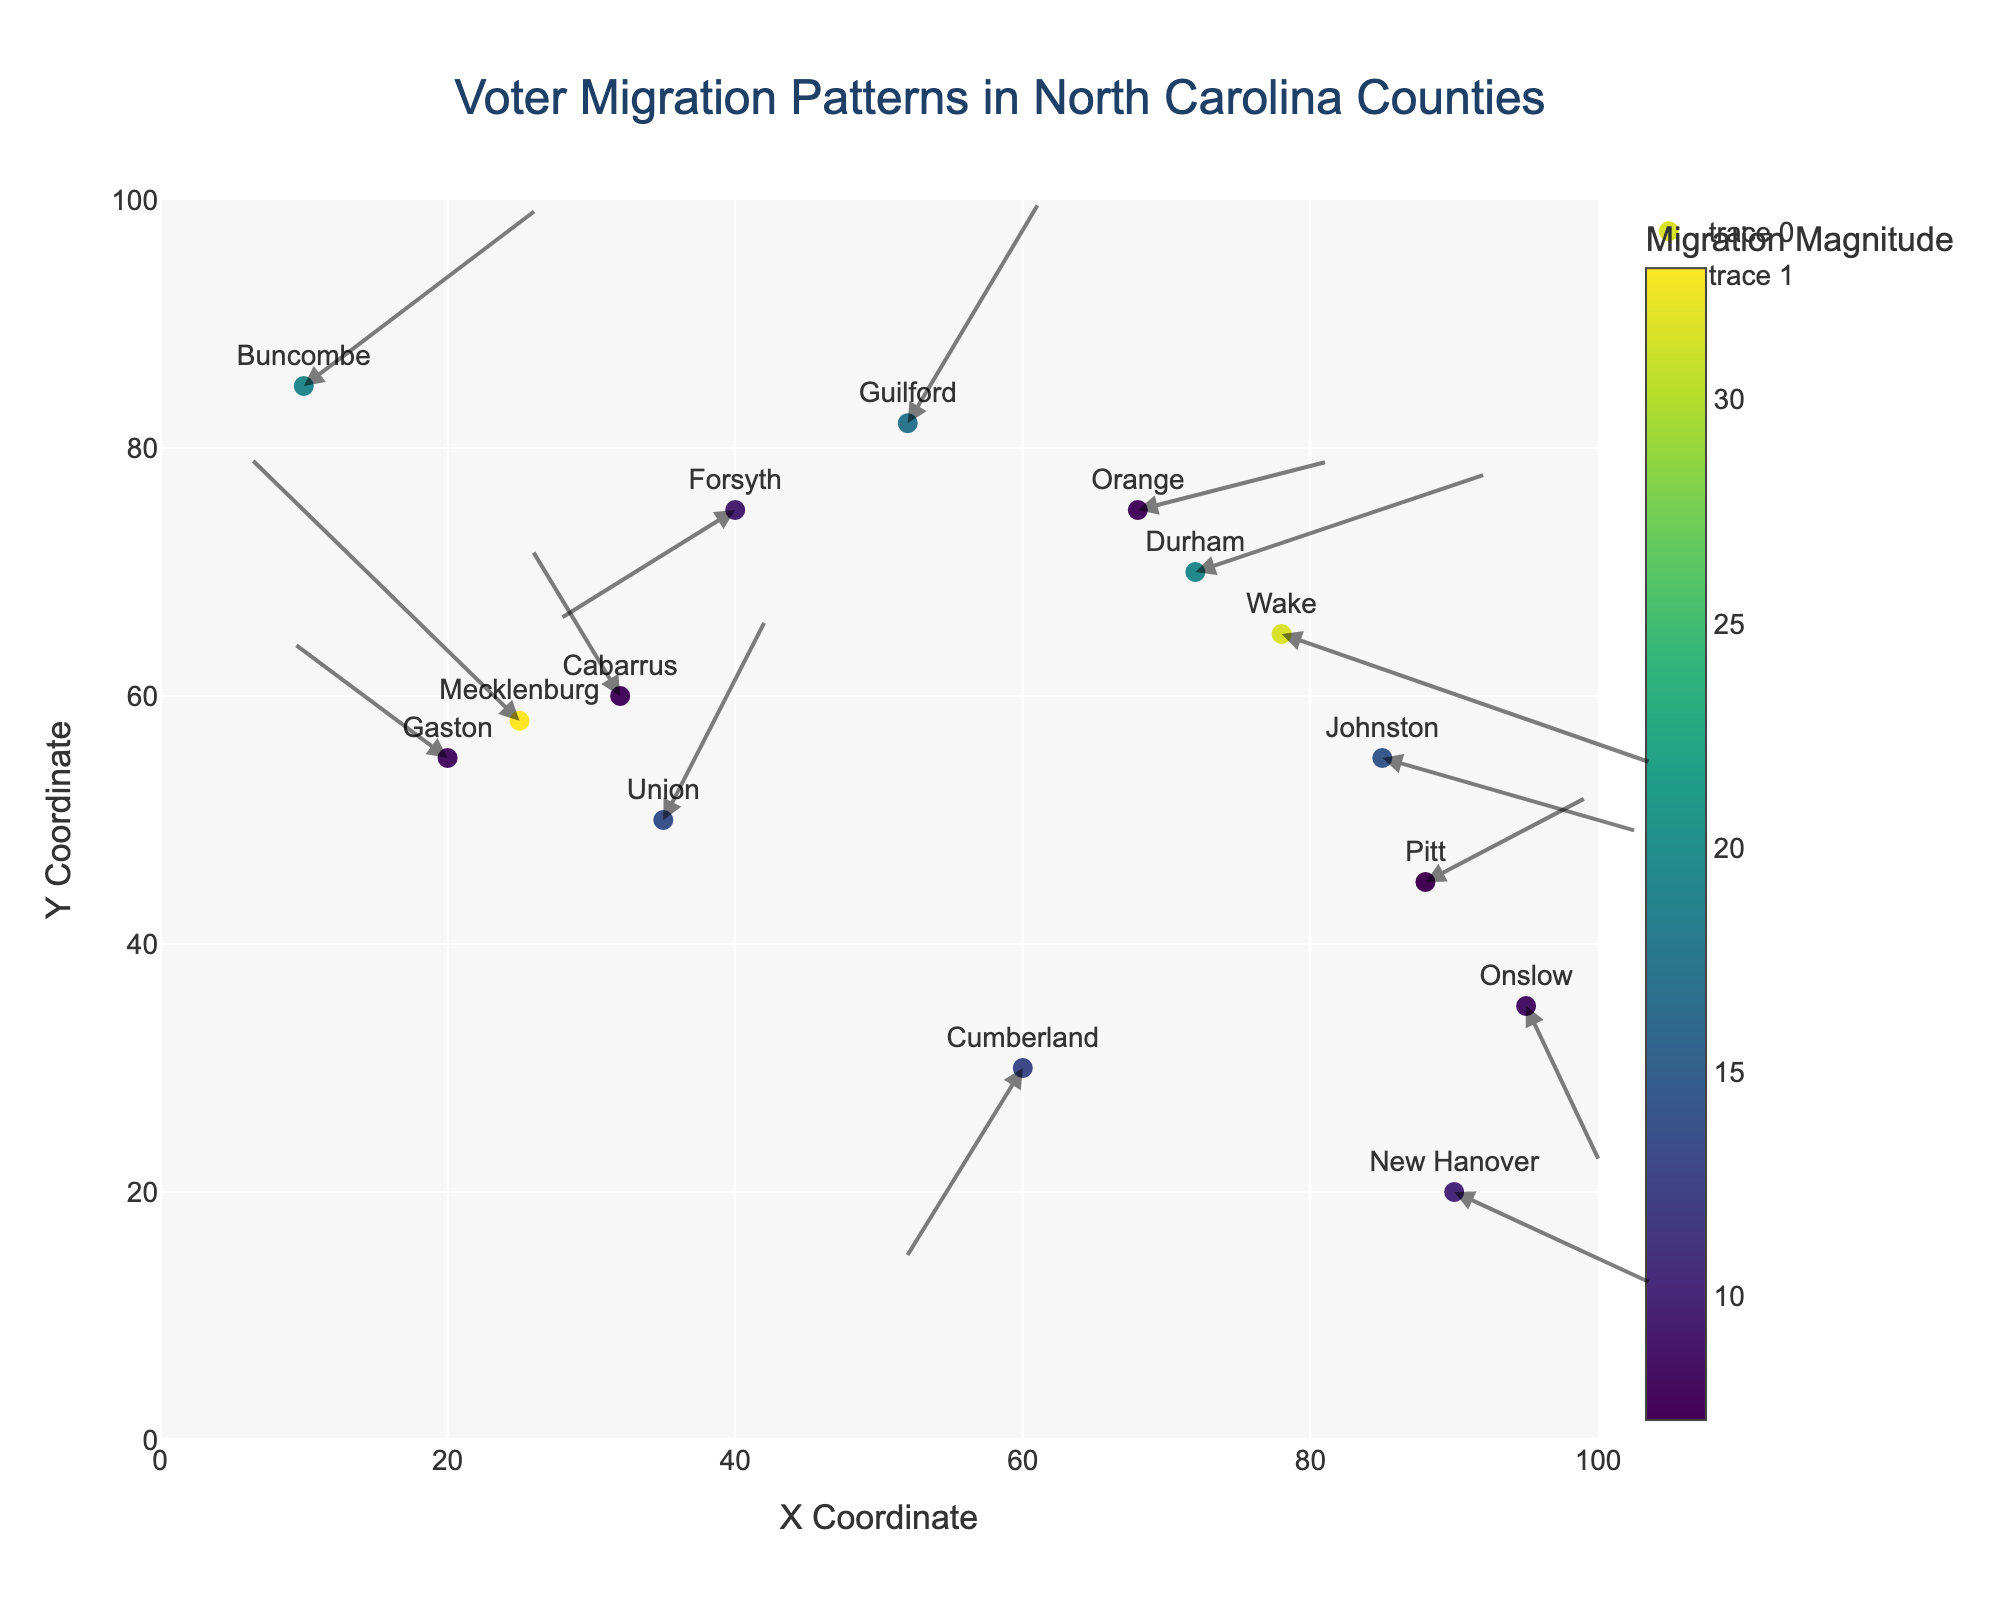What is the title of the plot? The title is displayed prominently at the top of the plot, indicating what the plot represents.
Answer: Voter Migration Patterns in North Carolina Counties Which county has the highest magnitude of migration? By looking at the colors of the markers, which indicate the migration magnitude, we can identify the county with the darkest color.
Answer: Buncombe How many counties have negative X direction migration? Count the number of vectors (arrows) pointing to the left. Counties with negative X direction migration are Mecklenburg, Forsyth, Cumberland, Gaston, and Cabarrus.
Answer: 5 What is the Y-coordinate of Wake County? Locate Wake County on the plot and check its Y-coordinate position.
Answer: 65 Which counties show migration patterns towards the south-east? Identify arrows pointing mainly downwards and to the right. Counties migrating to the south-east are Wake, Durham, New Hanover, Johnston, and Onslow.
Answer: 5 Which two counties have both positive X and Y migration values? Find counties with arrows pointing towards the top-right. The two counties are Guilford and Buncombe.
Answer: 2 What is the average X migration value across all counties? Sum all the X migration values and divide by the total number of counties. The calculation is (5.2 - 3.8 + 1.9 - 2.5 + 4.1 - 1.7 + 3.3 + 2.8 - 2.2 + 1.5 + 2.7 - 1.3 + 3.6 + 1.1 + 2.3) / 15 = 1.46.
Answer: 1.46 Which county has the longest migration vector? The length of the migration vector can be identified by the length and the magnitude color. Buncombe has the longest migration vector.
Answer: Buncombe What are the X and Y migration values for Johnston County? Hover over the Johnston County marker to reveal the respective values.
Answer: 3.6, -1.2 